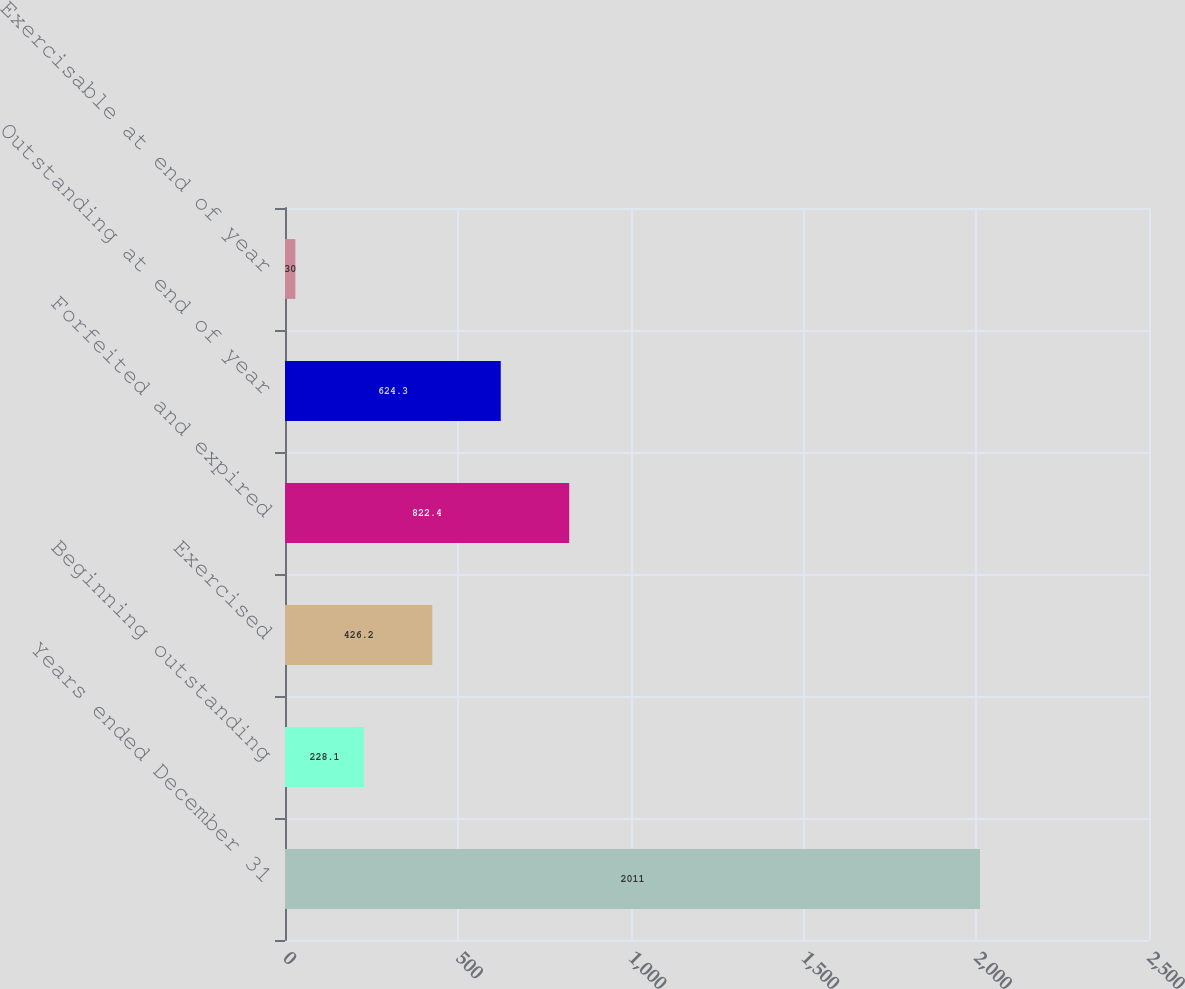<chart> <loc_0><loc_0><loc_500><loc_500><bar_chart><fcel>Years ended December 31<fcel>Beginning outstanding<fcel>Exercised<fcel>Forfeited and expired<fcel>Outstanding at end of year<fcel>Exercisable at end of year<nl><fcel>2011<fcel>228.1<fcel>426.2<fcel>822.4<fcel>624.3<fcel>30<nl></chart> 